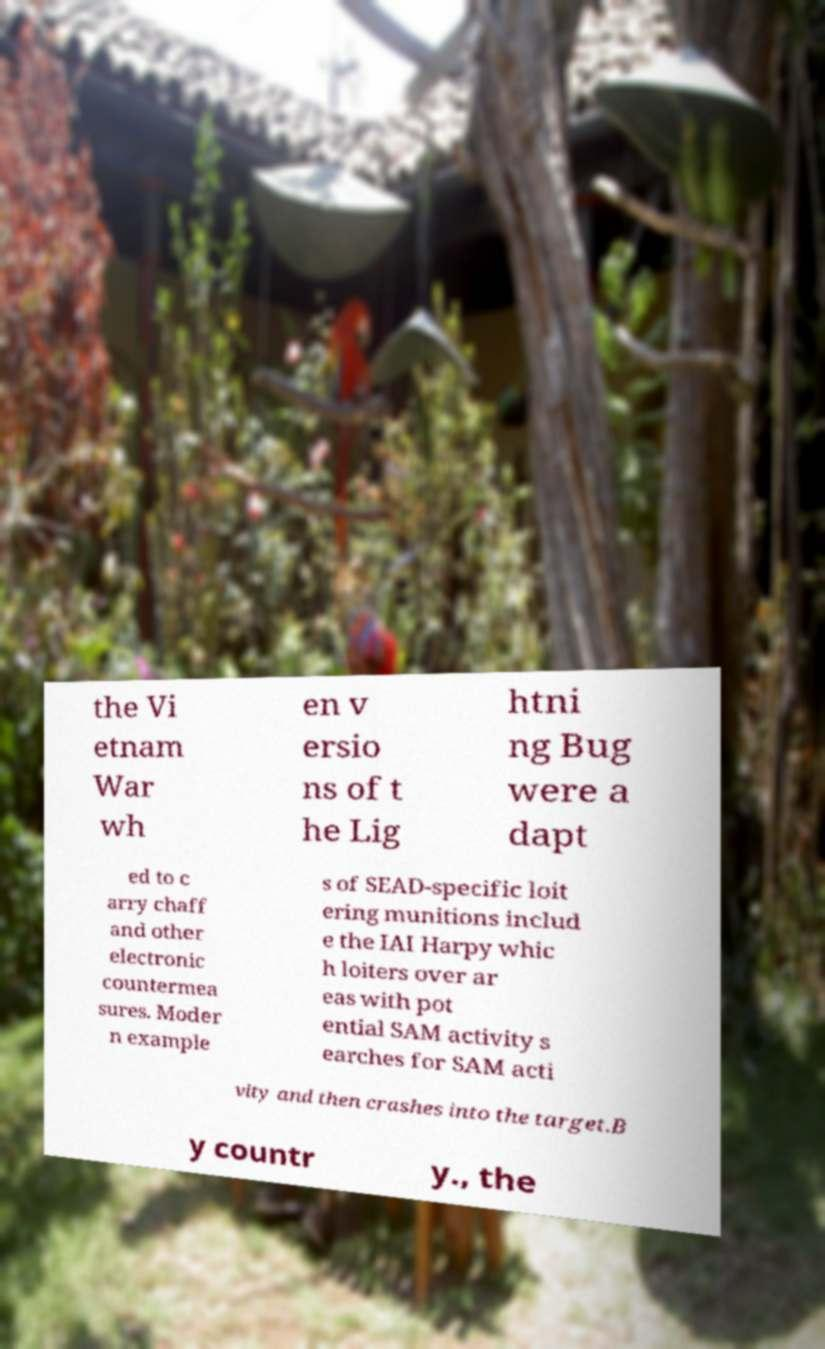Please read and relay the text visible in this image. What does it say? the Vi etnam War wh en v ersio ns of t he Lig htni ng Bug were a dapt ed to c arry chaff and other electronic countermea sures. Moder n example s of SEAD-specific loit ering munitions includ e the IAI Harpy whic h loiters over ar eas with pot ential SAM activity s earches for SAM acti vity and then crashes into the target.B y countr y., the 